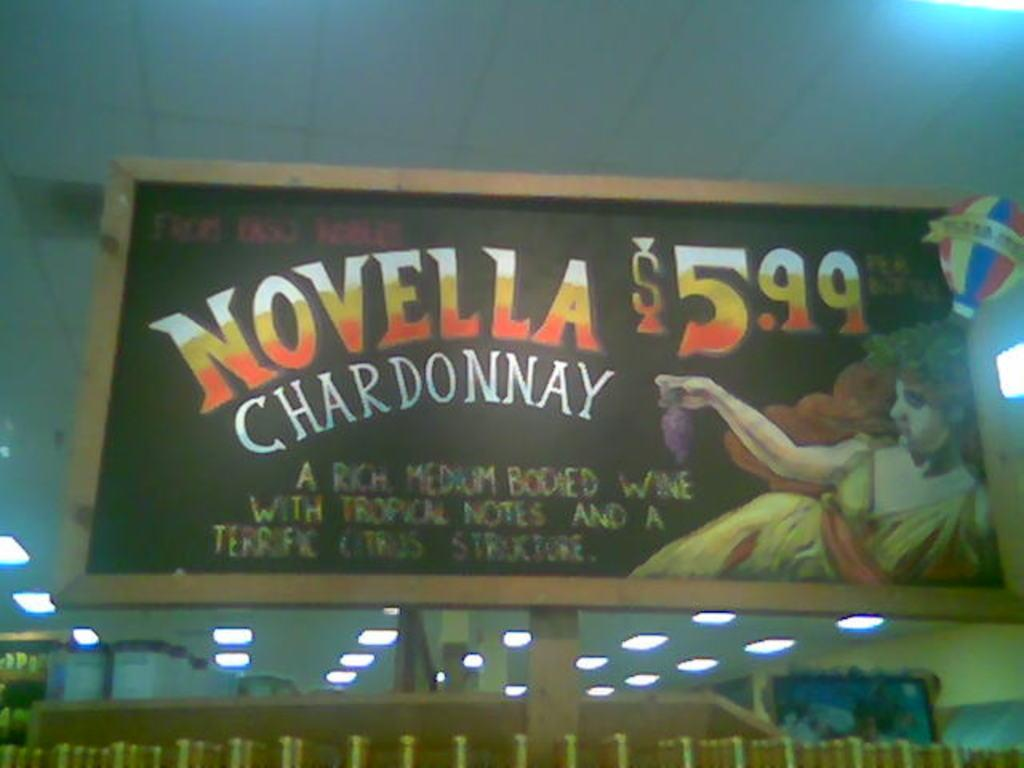<image>
Create a compact narrative representing the image presented. A large sign in a grocery store says Novella Chardonnay $5.99. 